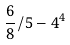Convert formula to latex. <formula><loc_0><loc_0><loc_500><loc_500>\frac { 6 } { 8 } / 5 - 4 ^ { 4 }</formula> 